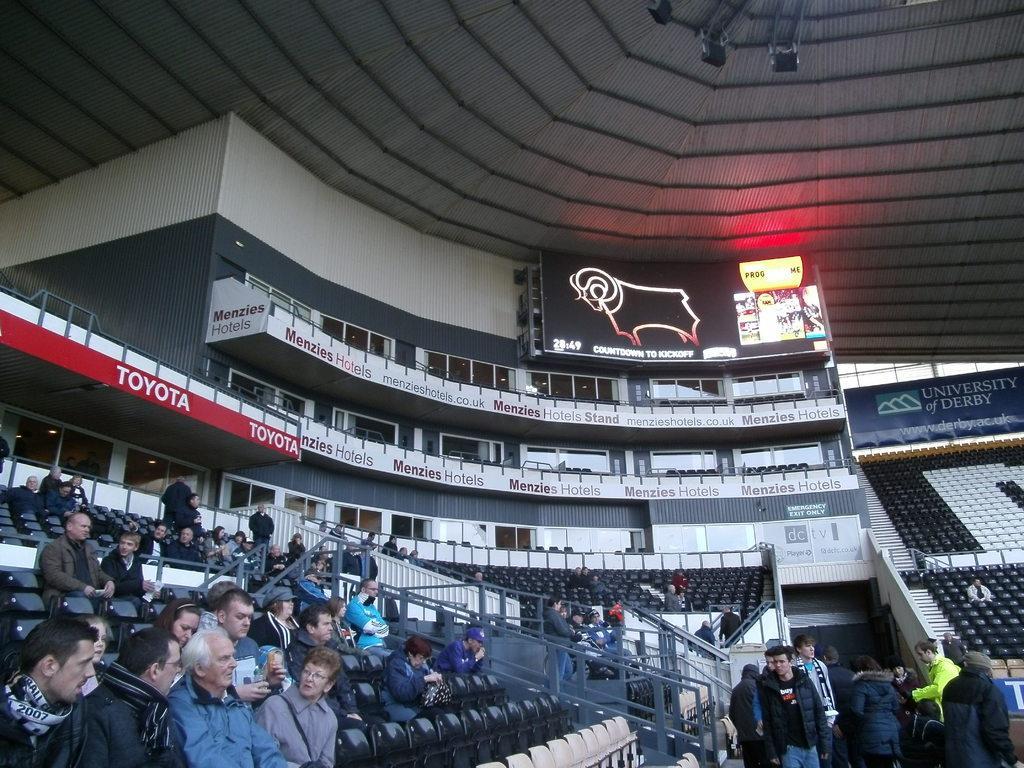Could you give a brief overview of what you see in this image? In this picture there is a inside view of the stadium hall. In the front there are many audience sitting on the seats. Behind there are some balcony railings. On the top we can see the scoreboard and roofing tile shed on the ceiling. 